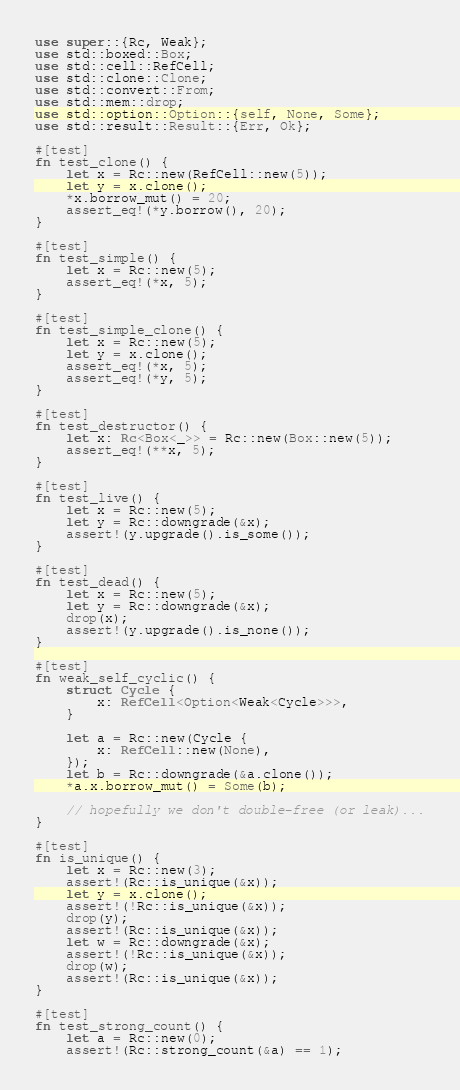Convert code to text. <code><loc_0><loc_0><loc_500><loc_500><_Rust_>use super::{Rc, Weak};
use std::boxed::Box;
use std::cell::RefCell;
use std::clone::Clone;
use std::convert::From;
use std::mem::drop;
use std::option::Option::{self, None, Some};
use std::result::Result::{Err, Ok};

#[test]
fn test_clone() {
    let x = Rc::new(RefCell::new(5));
    let y = x.clone();
    *x.borrow_mut() = 20;
    assert_eq!(*y.borrow(), 20);
}

#[test]
fn test_simple() {
    let x = Rc::new(5);
    assert_eq!(*x, 5);
}

#[test]
fn test_simple_clone() {
    let x = Rc::new(5);
    let y = x.clone();
    assert_eq!(*x, 5);
    assert_eq!(*y, 5);
}

#[test]
fn test_destructor() {
    let x: Rc<Box<_>> = Rc::new(Box::new(5));
    assert_eq!(**x, 5);
}

#[test]
fn test_live() {
    let x = Rc::new(5);
    let y = Rc::downgrade(&x);
    assert!(y.upgrade().is_some());
}

#[test]
fn test_dead() {
    let x = Rc::new(5);
    let y = Rc::downgrade(&x);
    drop(x);
    assert!(y.upgrade().is_none());
}

#[test]
fn weak_self_cyclic() {
    struct Cycle {
        x: RefCell<Option<Weak<Cycle>>>,
    }

    let a = Rc::new(Cycle {
        x: RefCell::new(None),
    });
    let b = Rc::downgrade(&a.clone());
    *a.x.borrow_mut() = Some(b);

    // hopefully we don't double-free (or leak)...
}

#[test]
fn is_unique() {
    let x = Rc::new(3);
    assert!(Rc::is_unique(&x));
    let y = x.clone();
    assert!(!Rc::is_unique(&x));
    drop(y);
    assert!(Rc::is_unique(&x));
    let w = Rc::downgrade(&x);
    assert!(!Rc::is_unique(&x));
    drop(w);
    assert!(Rc::is_unique(&x));
}

#[test]
fn test_strong_count() {
    let a = Rc::new(0);
    assert!(Rc::strong_count(&a) == 1);</code> 